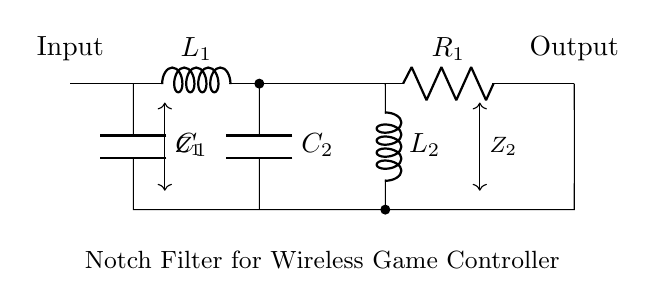What components are used in the notch filter? The circuit contains two inductors (L1 and L2), two capacitors (C1 and C2), and one resistor (R1). These components form the basic structure of the notch filter.
Answer: Inductors, capacitors, resistor What is the role of capacitor C2 in the circuit? Capacitor C2 is part of the notch filter design and contributes to creating the specific frequency response by blocking certain frequencies while allowing others to pass, thus filtering out interference.
Answer: Frequency response How many inductors are present in the diagram? There are two inductors labeled L1 and L2 in the circuit. This influences the filter's behavior at the notch frequency.
Answer: Two What is the output of the circuit connected to? The output is connected to a node that allows the filtered signal to be output for further processing or use in a wireless game controller application.
Answer: Filtered signal What does the notch filter achieve for a wireless game controller? The notch filter specifically targets and eliminates interference signals from other devices, enhancing the clarity and performance of the controller's communication.
Answer: Eliminates interference What is the connection configuration of the components? The components are connected in a specific series-parallel arrangement that characterizes a notch filter, allowing it to selectively attenuate defined frequencies depending on the values of L1, L2, C1, and C2.
Answer: Series-parallel arrangement What is the impedance between the nodes labeled Z1 and Z2? The impedances Z1 and Z2 represent the impedance points across the components, which shape the frequency response of the filter. Z1 connects to the input while Z2 connects to the output, affecting how the filter operates.
Answer: Impedance points 